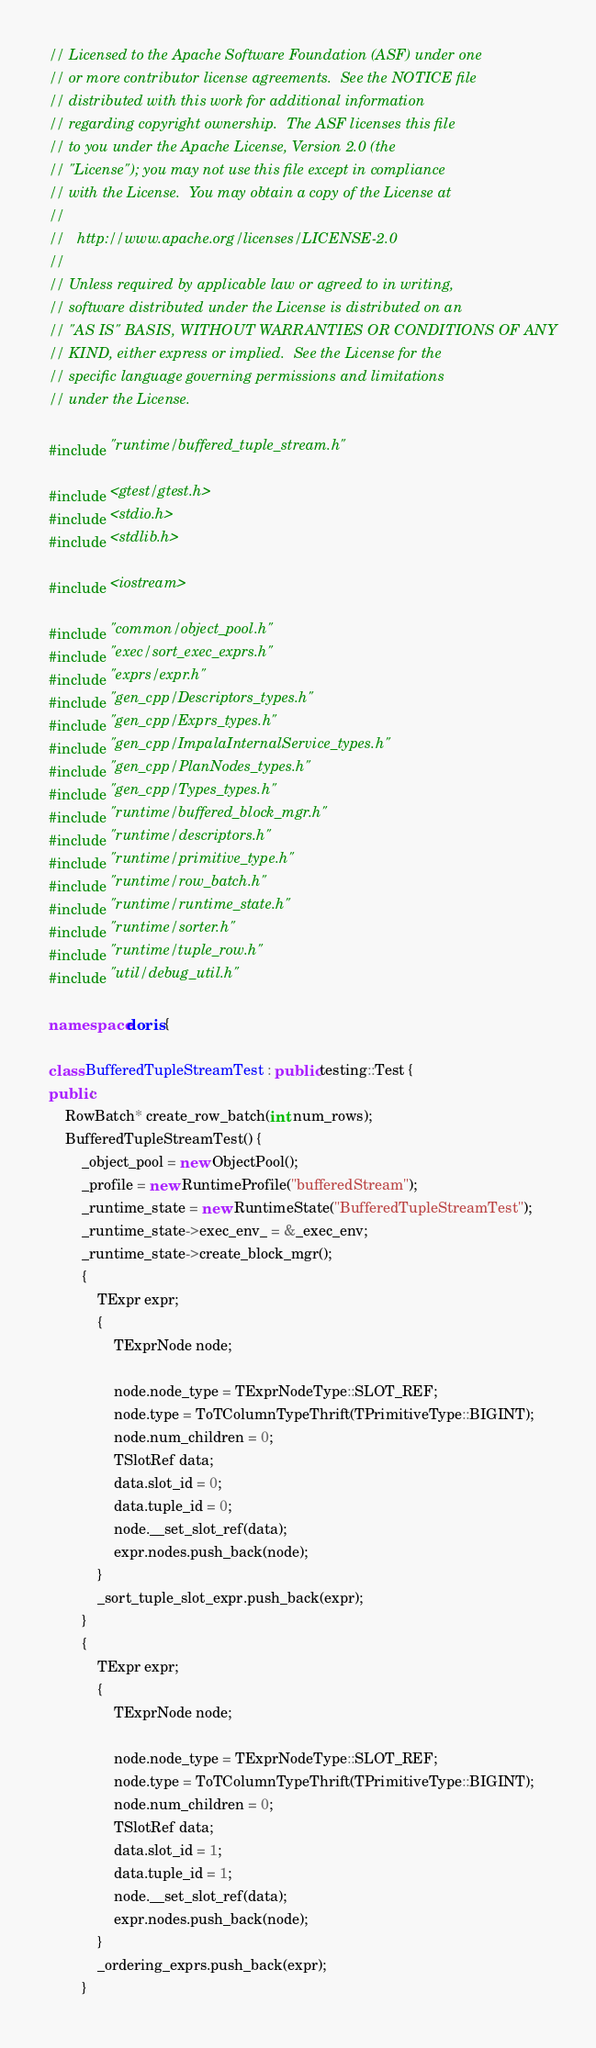Convert code to text. <code><loc_0><loc_0><loc_500><loc_500><_C++_>// Licensed to the Apache Software Foundation (ASF) under one
// or more contributor license agreements.  See the NOTICE file
// distributed with this work for additional information
// regarding copyright ownership.  The ASF licenses this file
// to you under the Apache License, Version 2.0 (the
// "License"); you may not use this file except in compliance
// with the License.  You may obtain a copy of the License at
//
//   http://www.apache.org/licenses/LICENSE-2.0
//
// Unless required by applicable law or agreed to in writing,
// software distributed under the License is distributed on an
// "AS IS" BASIS, WITHOUT WARRANTIES OR CONDITIONS OF ANY
// KIND, either express or implied.  See the License for the
// specific language governing permissions and limitations
// under the License.

#include "runtime/buffered_tuple_stream.h"

#include <gtest/gtest.h>
#include <stdio.h>
#include <stdlib.h>

#include <iostream>

#include "common/object_pool.h"
#include "exec/sort_exec_exprs.h"
#include "exprs/expr.h"
#include "gen_cpp/Descriptors_types.h"
#include "gen_cpp/Exprs_types.h"
#include "gen_cpp/ImpalaInternalService_types.h"
#include "gen_cpp/PlanNodes_types.h"
#include "gen_cpp/Types_types.h"
#include "runtime/buffered_block_mgr.h"
#include "runtime/descriptors.h"
#include "runtime/primitive_type.h"
#include "runtime/row_batch.h"
#include "runtime/runtime_state.h"
#include "runtime/sorter.h"
#include "runtime/tuple_row.h"
#include "util/debug_util.h"

namespace doris {

class BufferedTupleStreamTest : public testing::Test {
public:
    RowBatch* create_row_batch(int num_rows);
    BufferedTupleStreamTest() {
        _object_pool = new ObjectPool();
        _profile = new RuntimeProfile("bufferedStream");
        _runtime_state = new RuntimeState("BufferedTupleStreamTest");
        _runtime_state->exec_env_ = &_exec_env;
        _runtime_state->create_block_mgr();
        {
            TExpr expr;
            {
                TExprNode node;

                node.node_type = TExprNodeType::SLOT_REF;
                node.type = ToTColumnTypeThrift(TPrimitiveType::BIGINT);
                node.num_children = 0;
                TSlotRef data;
                data.slot_id = 0;
                data.tuple_id = 0;
                node.__set_slot_ref(data);
                expr.nodes.push_back(node);
            }
            _sort_tuple_slot_expr.push_back(expr);
        }
        {
            TExpr expr;
            {
                TExprNode node;

                node.node_type = TExprNodeType::SLOT_REF;
                node.type = ToTColumnTypeThrift(TPrimitiveType::BIGINT);
                node.num_children = 0;
                TSlotRef data;
                data.slot_id = 1;
                data.tuple_id = 1;
                node.__set_slot_ref(data);
                expr.nodes.push_back(node);
            }
            _ordering_exprs.push_back(expr);
        }</code> 